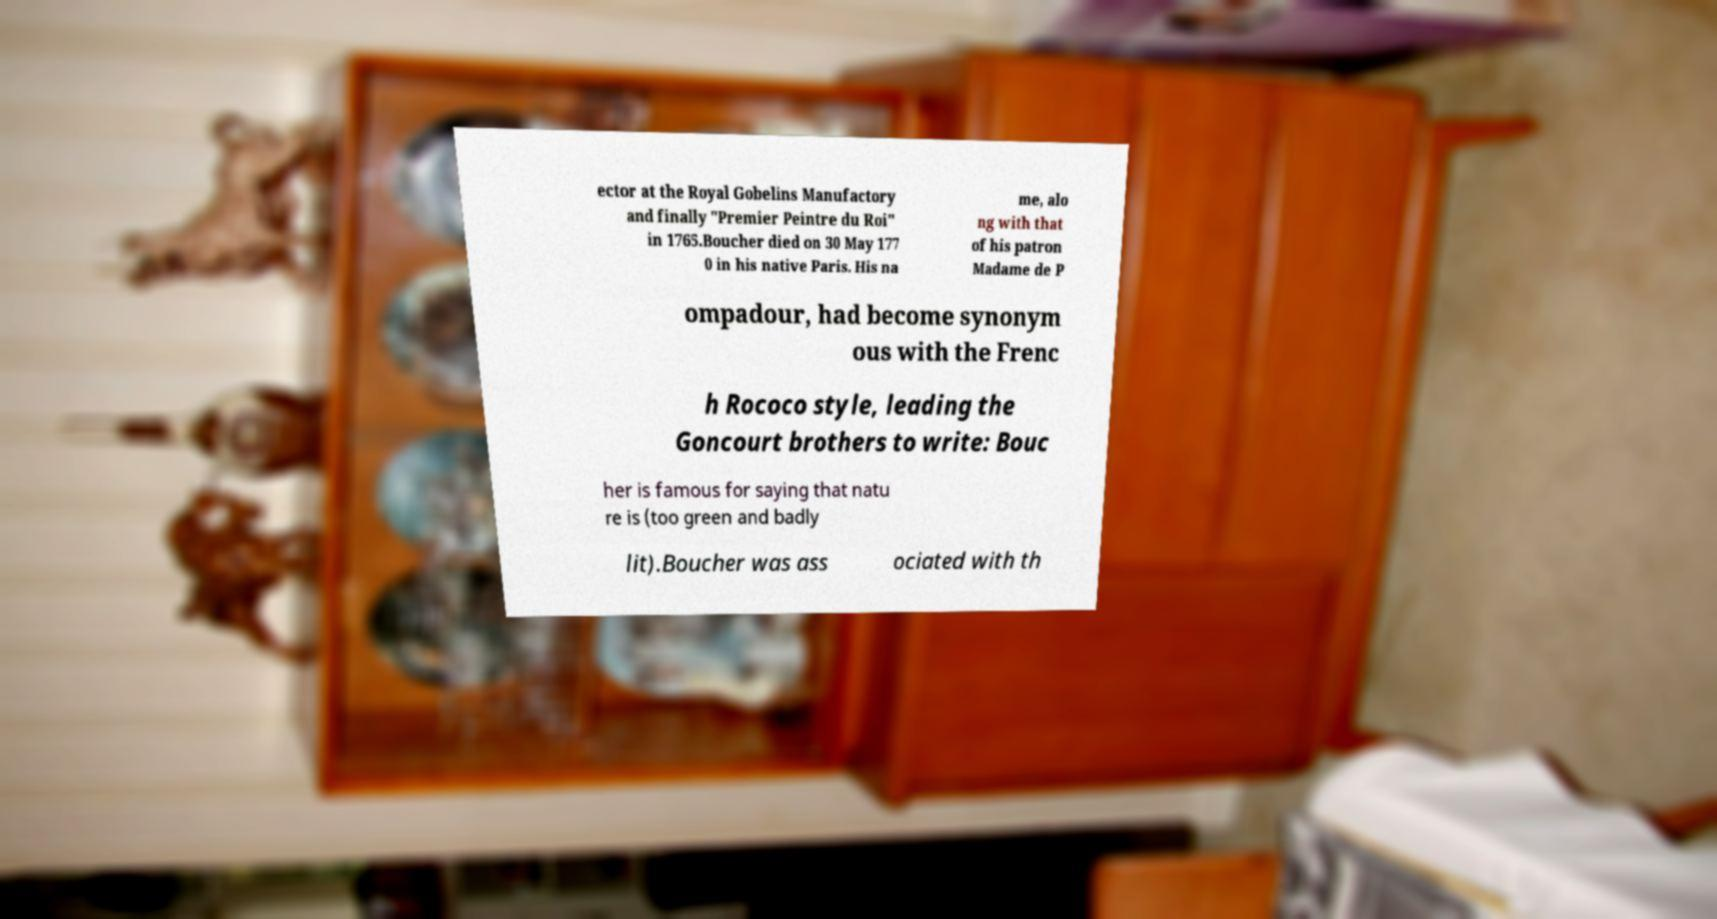There's text embedded in this image that I need extracted. Can you transcribe it verbatim? ector at the Royal Gobelins Manufactory and finally "Premier Peintre du Roi" in 1765.Boucher died on 30 May 177 0 in his native Paris. His na me, alo ng with that of his patron Madame de P ompadour, had become synonym ous with the Frenc h Rococo style, leading the Goncourt brothers to write: Bouc her is famous for saying that natu re is (too green and badly lit).Boucher was ass ociated with th 